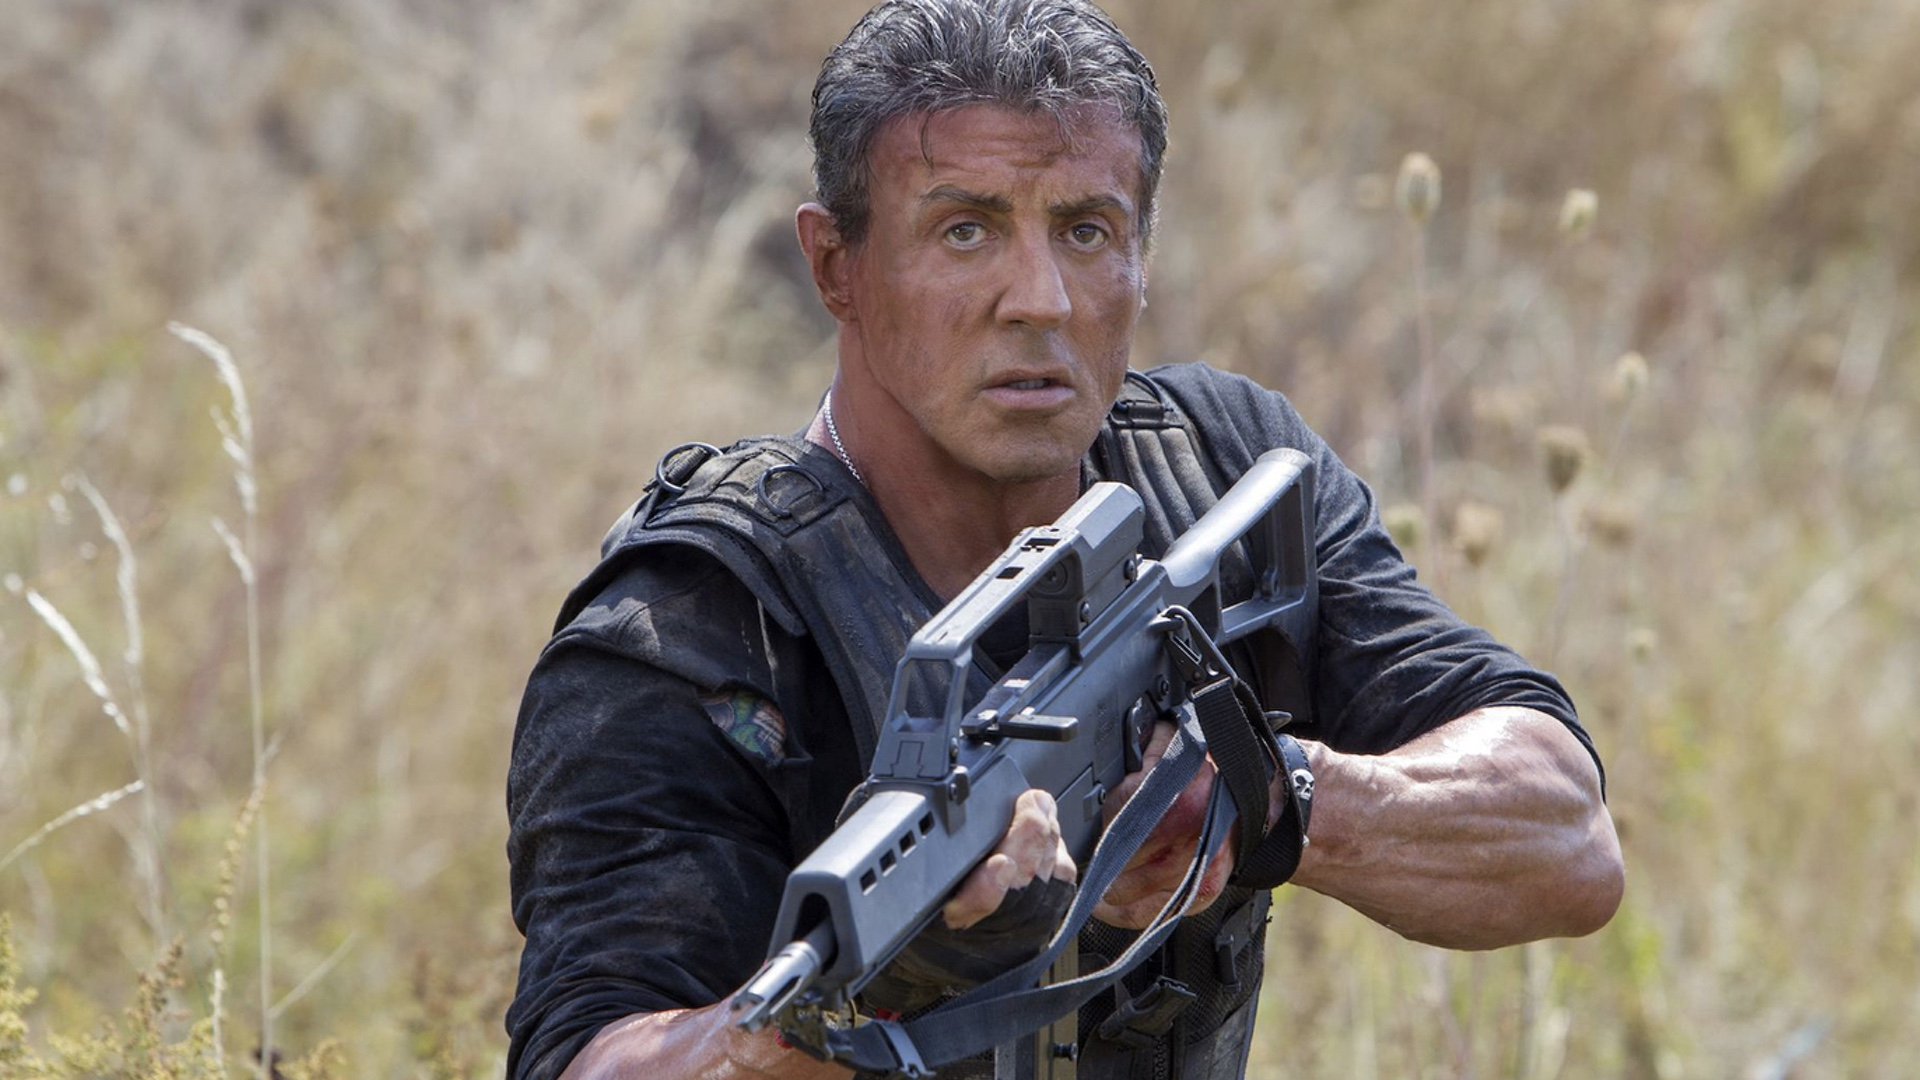Describe a realistic scenario depicted in this image in a few sentences. In this realistic scenario, the character is a soldier on a reconnaissance mission in a war-torn region. His intense focus and readiness suggest he is on high alert, surveying the area for potential threats while awaiting instructions for his next move. 